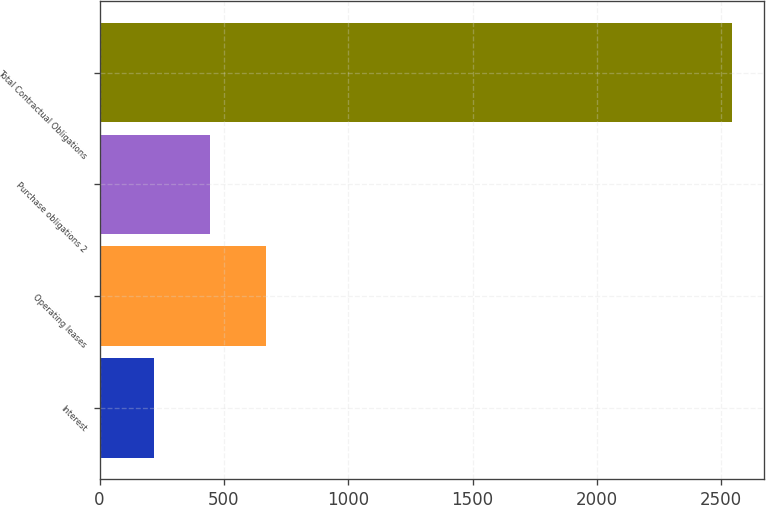Convert chart to OTSL. <chart><loc_0><loc_0><loc_500><loc_500><bar_chart><fcel>Interest<fcel>Operating leases<fcel>Purchase obligations 2<fcel>Total Contractual Obligations<nl><fcel>219<fcel>669.46<fcel>444.23<fcel>2545.13<nl></chart> 